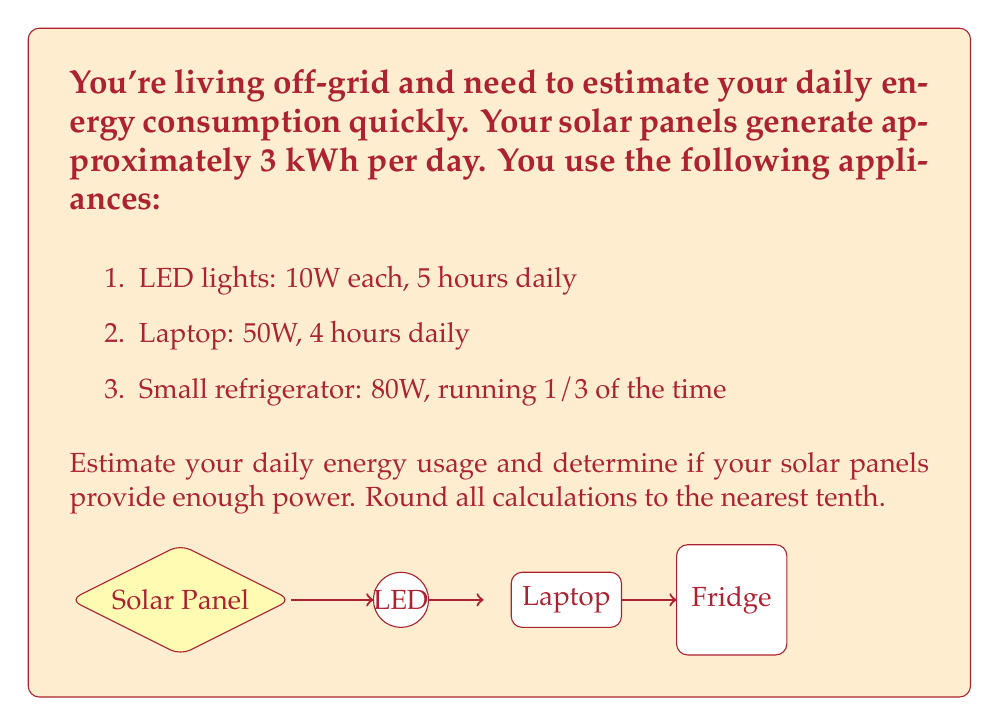Provide a solution to this math problem. Let's break this down step-by-step using mental math techniques:

1. LED lights:
   - Power: $10\text{W} = 0.01\text{kW}$
   - Daily usage: $0.01\text{kW} \times 5\text{h} = 0.05\text{kWh}$

2. Laptop:
   - Power: $50\text{W} = 0.05\text{kW}$
   - Daily usage: $0.05\text{kW} \times 4\text{h} = 0.2\text{kWh}$

3. Small refrigerator:
   - Power: $80\text{W} = 0.08\text{kW}$
   - Running time: $24\text{h} \times \frac{1}{3} = 8\text{h}$
   - Daily usage: $0.08\text{kW} \times 8\text{h} = 0.64\text{kWh}$

Now, let's sum up the total daily energy consumption:
$$0.05 + 0.2 + 0.64 = 0.89\text{kWh}$$

Rounding to the nearest tenth: $0.9\text{kWh}$

Comparing with solar panel output:
Solar panels generate $3\text{kWh}$ per day, which is more than the estimated usage of $0.9\text{kWh}$.

$3\text{kWh} > 0.9\text{kWh}$
Answer: $0.9\text{kWh}$; Yes, sufficient power 